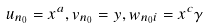Convert formula to latex. <formula><loc_0><loc_0><loc_500><loc_500>u _ { n _ { 0 } } = x ^ { a } , v _ { n _ { 0 } } = y , w _ { n _ { 0 } i } = x ^ { c } \gamma</formula> 